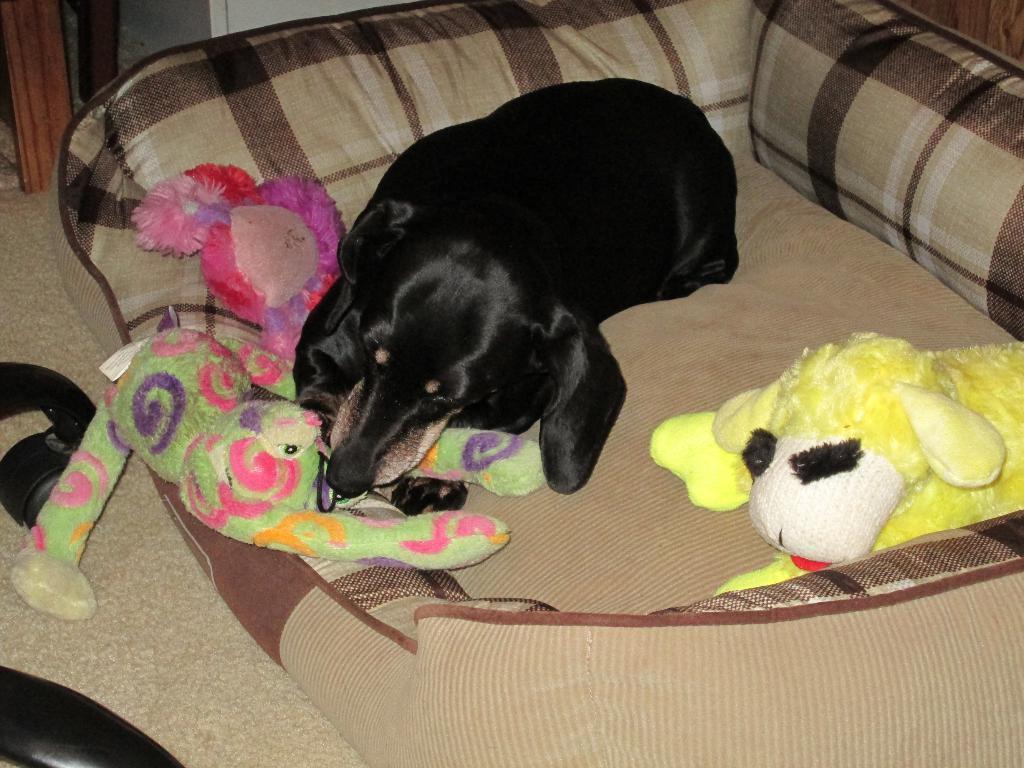In one or two sentences, can you explain what this image depicts? In this picture I can observe a black color dog laying on the sofa. There are some toys on the sofa. The sofa is in cream color. On the left side I can observe cream color curtain. 